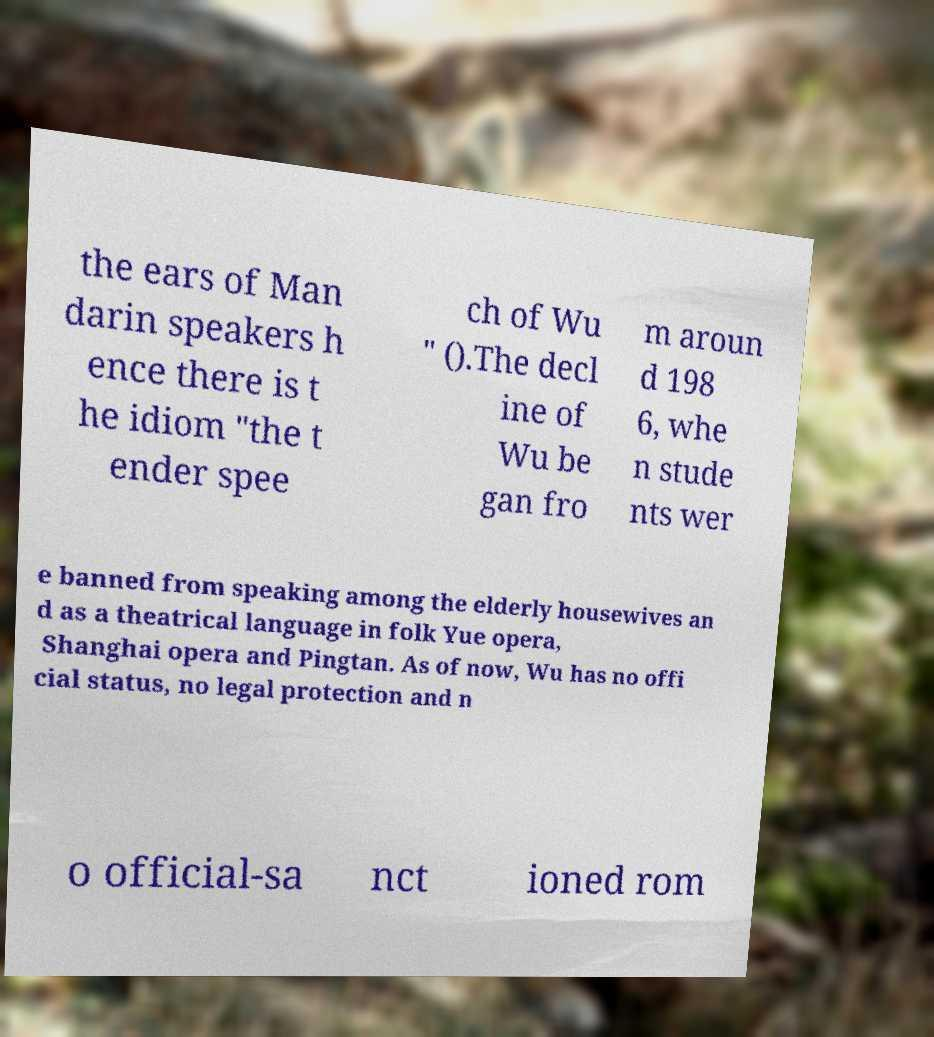Could you extract and type out the text from this image? the ears of Man darin speakers h ence there is t he idiom "the t ender spee ch of Wu " ().The decl ine of Wu be gan fro m aroun d 198 6, whe n stude nts wer e banned from speaking among the elderly housewives an d as a theatrical language in folk Yue opera, Shanghai opera and Pingtan. As of now, Wu has no offi cial status, no legal protection and n o official-sa nct ioned rom 